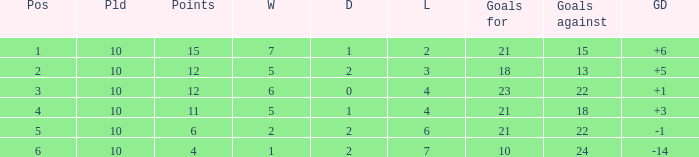Can you tell me the total number of Wins that has the Draws larger than 0, and the Points of 11? 1.0. 